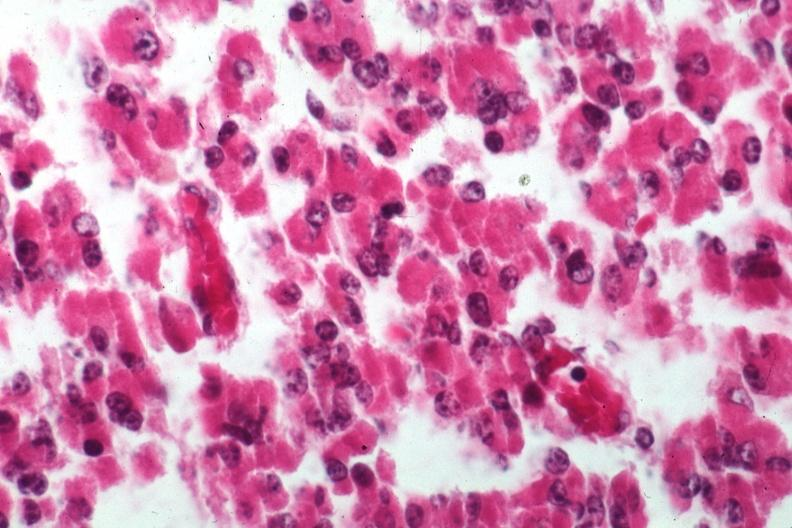what is present?
Answer the question using a single word or phrase. Eosinophilic adenoma 